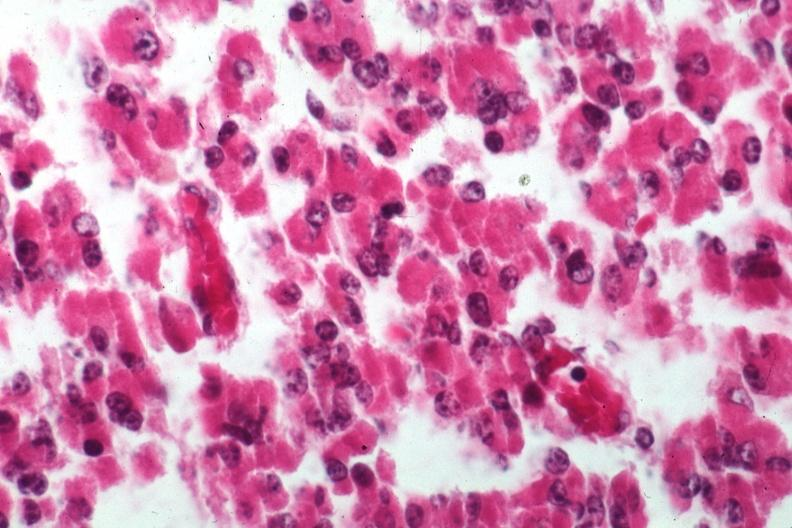what is present?
Answer the question using a single word or phrase. Eosinophilic adenoma 